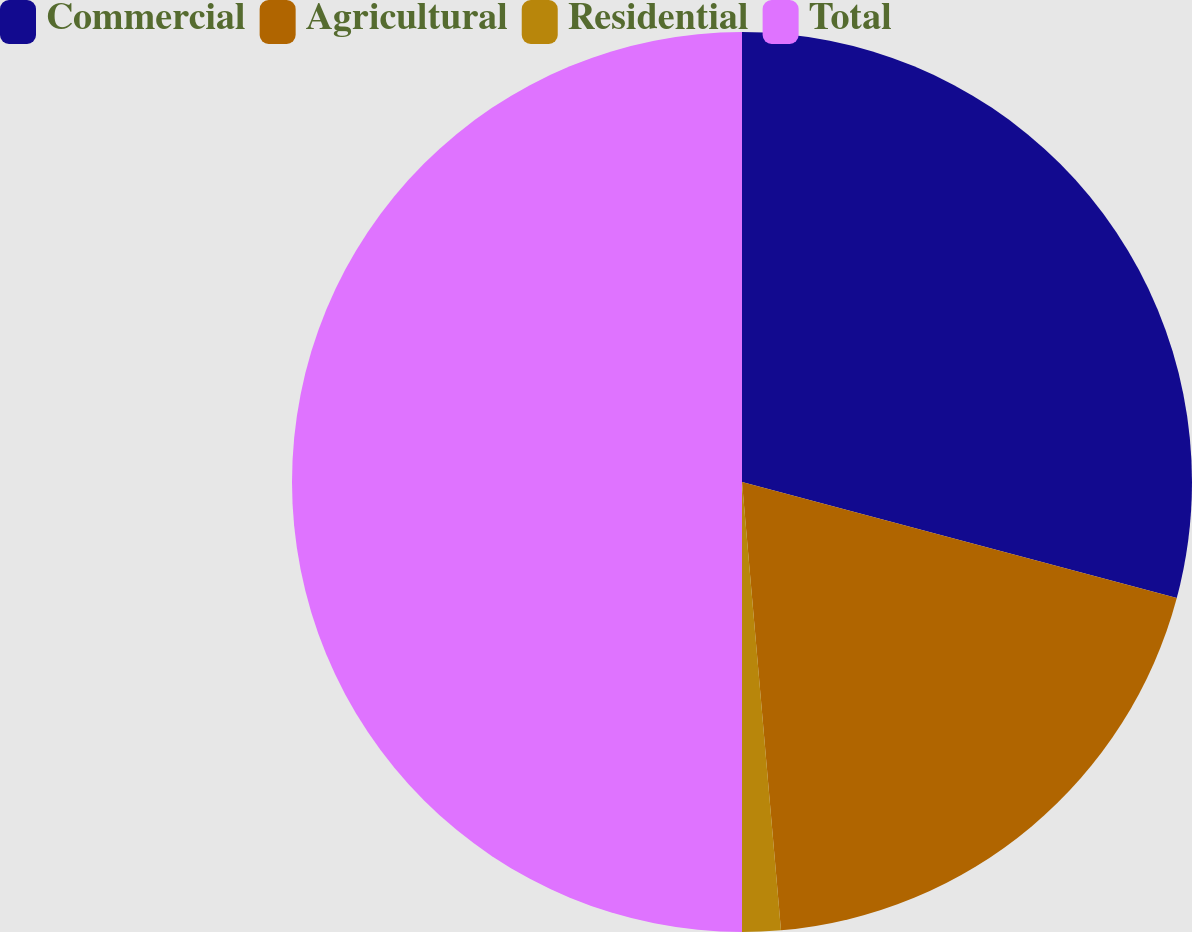Convert chart. <chart><loc_0><loc_0><loc_500><loc_500><pie_chart><fcel>Commercial<fcel>Agricultural<fcel>Residential<fcel>Total<nl><fcel>29.15%<fcel>19.47%<fcel>1.38%<fcel>50.0%<nl></chart> 